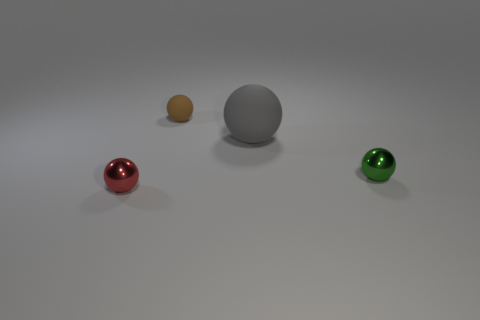There is a small ball that is in front of the shiny ball that is behind the tiny ball in front of the tiny green ball; what is it made of?
Your answer should be very brief. Metal. What material is the green sphere?
Make the answer very short. Metal. Do the green ball and the small brown object that is on the left side of the big gray thing have the same material?
Your answer should be compact. No. The tiny thing that is behind the metallic object behind the tiny red object is what color?
Ensure brevity in your answer.  Brown. How big is the object that is in front of the brown matte ball and behind the green thing?
Offer a very short reply. Large. What number of other objects are the same shape as the red metal thing?
Offer a terse response. 3. There is a small rubber thing; is its shape the same as the matte object to the right of the tiny brown object?
Give a very brief answer. Yes. There is a small red thing; what number of brown rubber balls are left of it?
Your answer should be very brief. 0. Is the shape of the object that is left of the small brown rubber thing the same as  the gray object?
Provide a succinct answer. Yes. There is a rubber sphere that is on the right side of the tiny brown matte ball; what is its color?
Provide a short and direct response. Gray. 